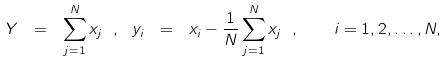Convert formula to latex. <formula><loc_0><loc_0><loc_500><loc_500>Y \ = \ \sum _ { j = 1 } ^ { N } x _ { j } \ , \ y _ { i } \ = \ x _ { i } - \frac { 1 } { N } \sum _ { j = 1 } ^ { N } x _ { j } \ , \quad i = 1 , 2 , \dots , N ,</formula> 